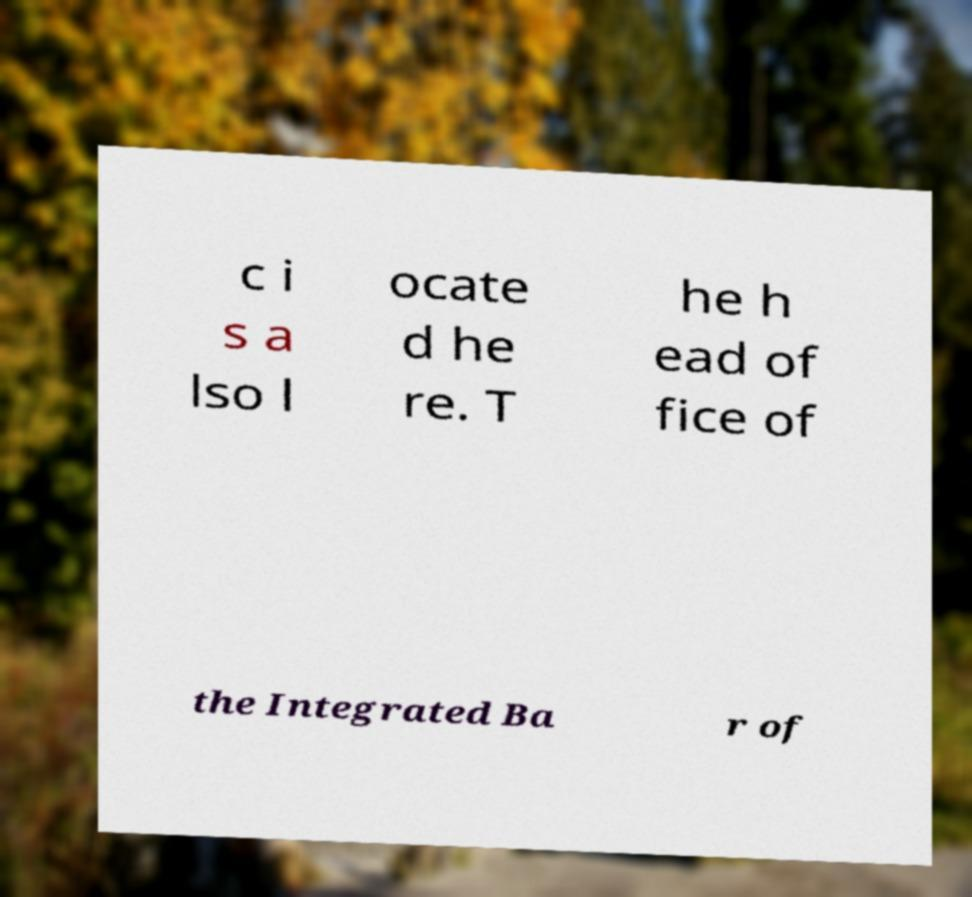Please read and relay the text visible in this image. What does it say? c i s a lso l ocate d he re. T he h ead of fice of the Integrated Ba r of 